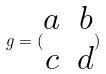Convert formula to latex. <formula><loc_0><loc_0><loc_500><loc_500>g = ( \begin{matrix} a & b \\ c & d \end{matrix} )</formula> 